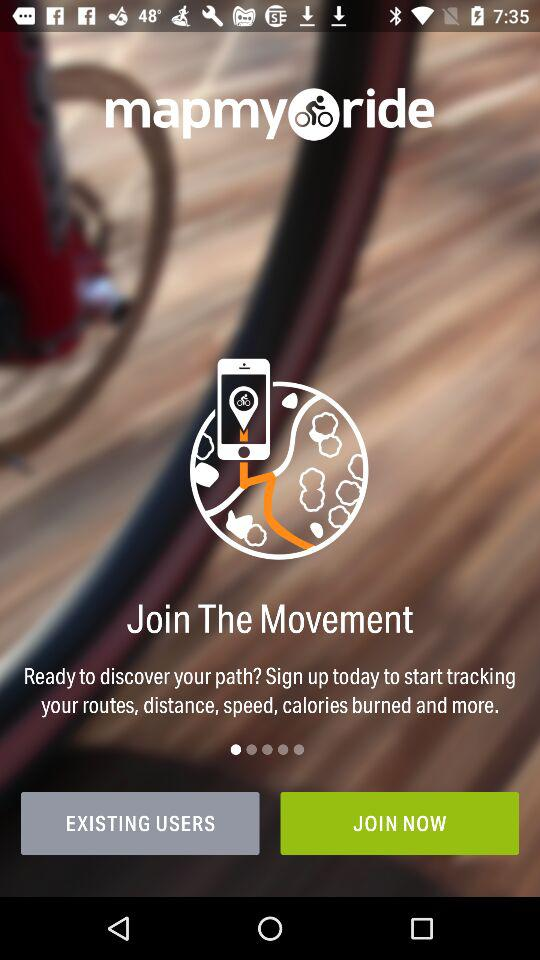What is the name of the application? The name of the application is "mapmyride". 